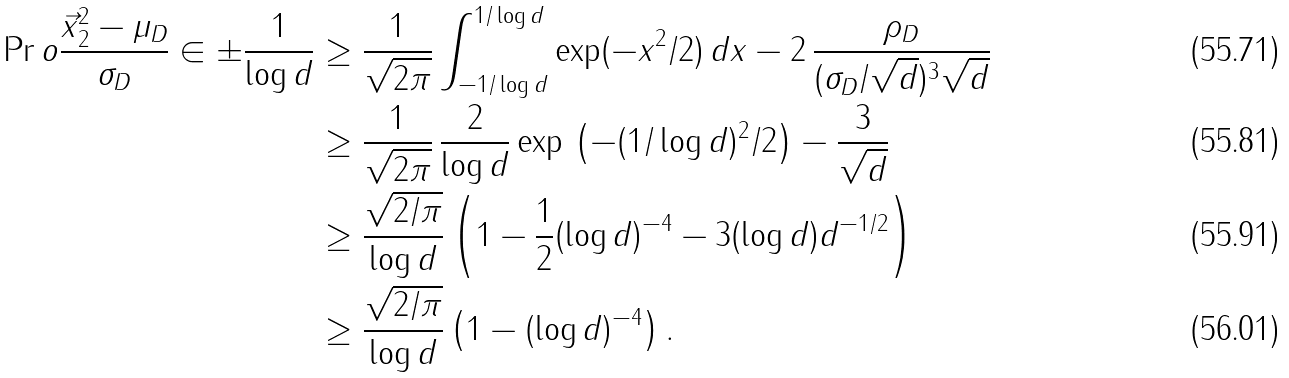<formula> <loc_0><loc_0><loc_500><loc_500>\Pr o { \frac { \| \vec { x } \| _ { 2 } ^ { 2 } - \mu _ { D } } { \sigma _ { D } } \in \pm \frac { 1 } { \log d } } & \geq \frac { 1 } { \sqrt { 2 \pi } } \int _ { - 1 / \log d } ^ { 1 / \log d } \exp ( - x ^ { 2 } / 2 ) \, d x - 2 \, \frac { \rho _ { D } } { ( \sigma _ { D } / \sqrt { d } ) ^ { 3 } \sqrt { d } } \\ & \geq \frac { 1 } { \sqrt { 2 \pi } } \, \frac { 2 } { \log d } \exp \, \left ( - ( 1 / \log d ) ^ { 2 } / 2 \right ) - \frac { 3 } { \sqrt { d } } \\ & \geq \frac { \sqrt { 2 / \pi } } { \log d } \left ( 1 - \frac { 1 } { 2 } ( \log d ) ^ { - 4 } - 3 ( \log d ) d ^ { - 1 / 2 } \right ) \\ & \geq \frac { \sqrt { 2 / \pi } } { \log d } \left ( 1 - ( \log d ) ^ { - 4 } \right ) .</formula> 